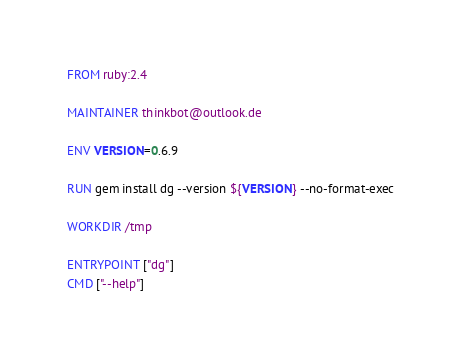Convert code to text. <code><loc_0><loc_0><loc_500><loc_500><_Dockerfile_>FROM ruby:2.4

MAINTAINER thinkbot@outlook.de

ENV VERSION=0.6.9

RUN gem install dg --version ${VERSION} --no-format-exec

WORKDIR /tmp

ENTRYPOINT ["dg"]
CMD ["--help"]
</code> 